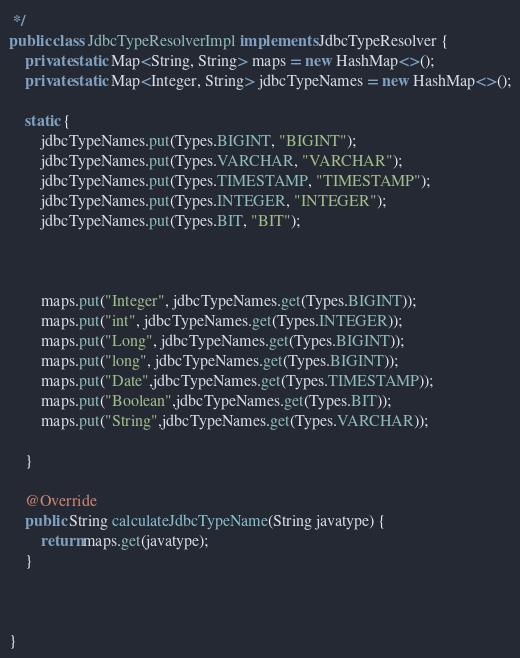Convert code to text. <code><loc_0><loc_0><loc_500><loc_500><_Java_> */
public class JdbcTypeResolverImpl implements JdbcTypeResolver {
    private static Map<String, String> maps = new HashMap<>();
    private static Map<Integer, String> jdbcTypeNames = new HashMap<>();

    static {
        jdbcTypeNames.put(Types.BIGINT, "BIGINT");
        jdbcTypeNames.put(Types.VARCHAR, "VARCHAR");
        jdbcTypeNames.put(Types.TIMESTAMP, "TIMESTAMP");
        jdbcTypeNames.put(Types.INTEGER, "INTEGER");
        jdbcTypeNames.put(Types.BIT, "BIT");



        maps.put("Integer", jdbcTypeNames.get(Types.BIGINT));
        maps.put("int", jdbcTypeNames.get(Types.INTEGER));
        maps.put("Long", jdbcTypeNames.get(Types.BIGINT));
        maps.put("long", jdbcTypeNames.get(Types.BIGINT));
        maps.put("Date",jdbcTypeNames.get(Types.TIMESTAMP));
        maps.put("Boolean",jdbcTypeNames.get(Types.BIT));
        maps.put("String",jdbcTypeNames.get(Types.VARCHAR));

    }

    @Override
    public String calculateJdbcTypeName(String javatype) {
        return maps.get(javatype);
    }



}
</code> 